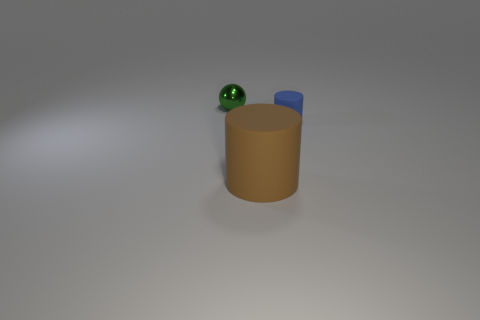Add 1 small purple cylinders. How many objects exist? 4 Subtract all spheres. How many objects are left? 2 Add 3 big brown objects. How many big brown objects exist? 4 Subtract 0 purple cubes. How many objects are left? 3 Subtract all small brown shiny things. Subtract all small blue matte things. How many objects are left? 2 Add 2 small objects. How many small objects are left? 4 